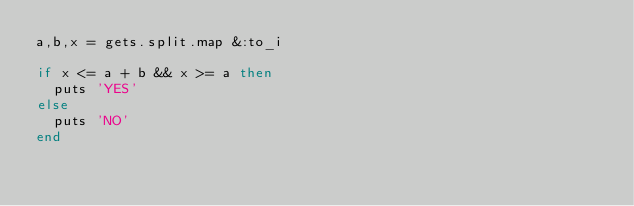<code> <loc_0><loc_0><loc_500><loc_500><_Ruby_>a,b,x = gets.split.map &:to_i

if x <= a + b && x >= a then
	puts 'YES'
else
	puts 'NO'
end</code> 